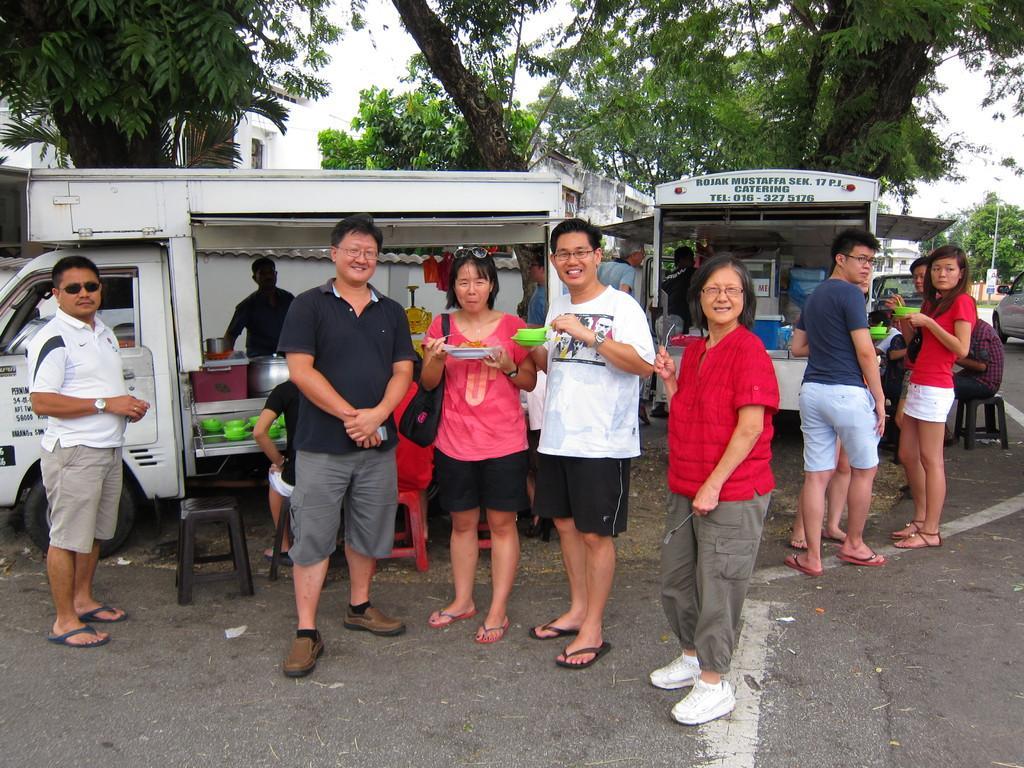In one or two sentences, can you explain what this image depicts? Here we can see people. Few people are holding objects. Background there are vehicles, trees and building. These are chairs. 